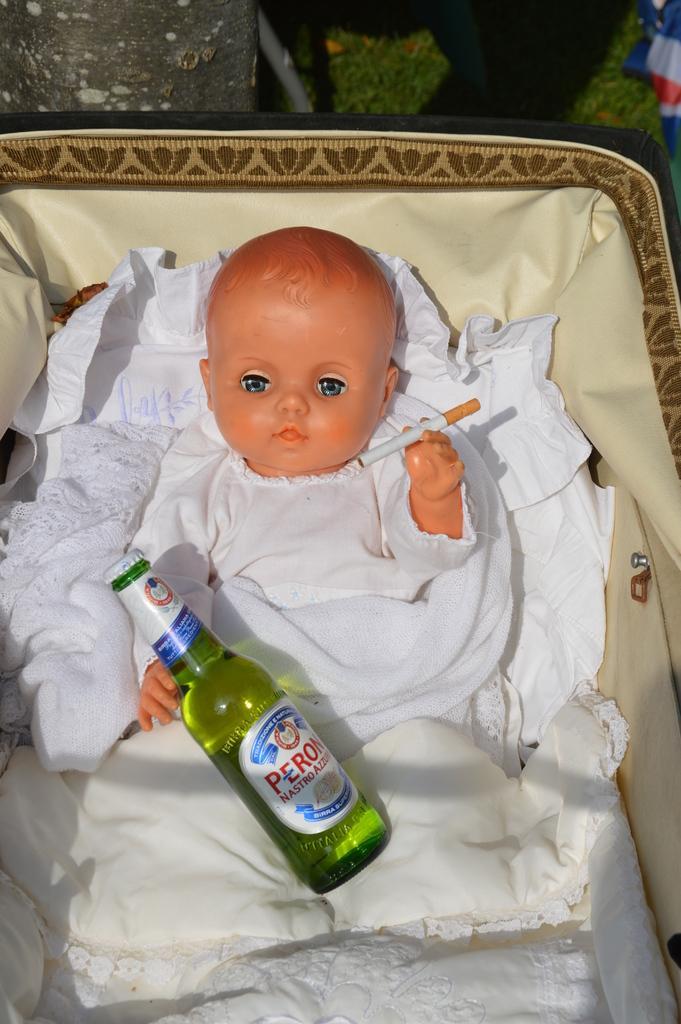Describe this image in one or two sentences. The boy was sitting in a chair. There is a bottle in his lap. He's holding a cigarette. 